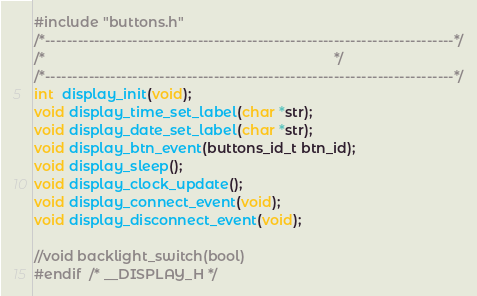<code> <loc_0><loc_0><loc_500><loc_500><_C_>#include "buttons.h"
/*---------------------------------------------------------------------------*/
/*                                                                           */
/*---------------------------------------------------------------------------*/
int  display_init(void);
void display_time_set_label(char *str);
void display_date_set_label(char *str);
void display_btn_event(buttons_id_t btn_id);
void display_sleep();
void display_clock_update();
void display_connect_event(void);
void display_disconnect_event(void);

//void backlight_switch(bool)
#endif  /* __DISPLAY_H */
</code> 